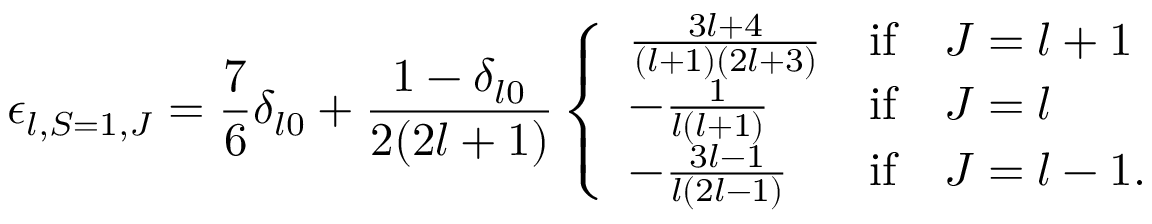Convert formula to latex. <formula><loc_0><loc_0><loc_500><loc_500>\epsilon _ { l , S = 1 , J } = \frac { 7 } { 6 } \delta _ { l 0 } + \frac { 1 - \delta _ { l 0 } } { 2 ( 2 l + 1 ) } \left \{ \begin{array} { l c l } { { \frac { 3 l + 4 } { ( l + 1 ) ( 2 l + 3 ) } } } & { i f } & { J = l + 1 } \\ { { - \frac { 1 } { l ( l + 1 ) } } } & { i f } & { J = l } \\ { { - \frac { 3 l - 1 } { l ( 2 l - 1 ) } } } & { i f } & { J = l - 1 . } \end{array}</formula> 